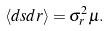<formula> <loc_0><loc_0><loc_500><loc_500>\langle d s d r \rangle = \sigma ^ { 2 } _ { r } \mu .</formula> 